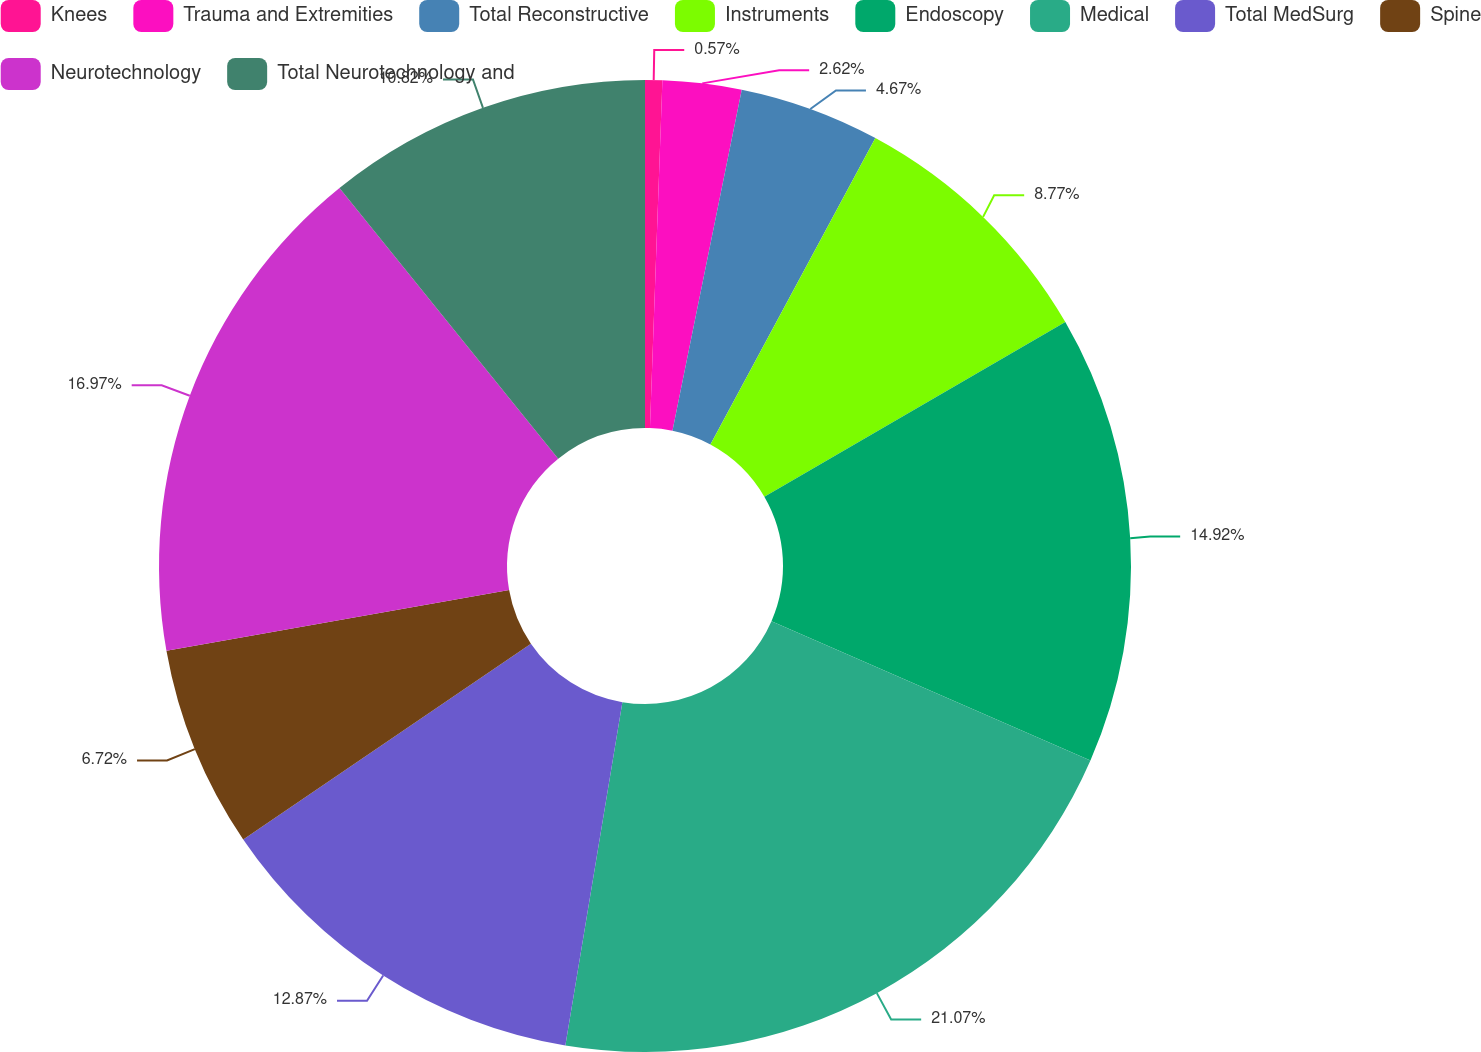Convert chart. <chart><loc_0><loc_0><loc_500><loc_500><pie_chart><fcel>Knees<fcel>Trauma and Extremities<fcel>Total Reconstructive<fcel>Instruments<fcel>Endoscopy<fcel>Medical<fcel>Total MedSurg<fcel>Spine<fcel>Neurotechnology<fcel>Total Neurotechnology and<nl><fcel>0.57%<fcel>2.62%<fcel>4.67%<fcel>8.77%<fcel>14.92%<fcel>21.07%<fcel>12.87%<fcel>6.72%<fcel>16.97%<fcel>10.82%<nl></chart> 